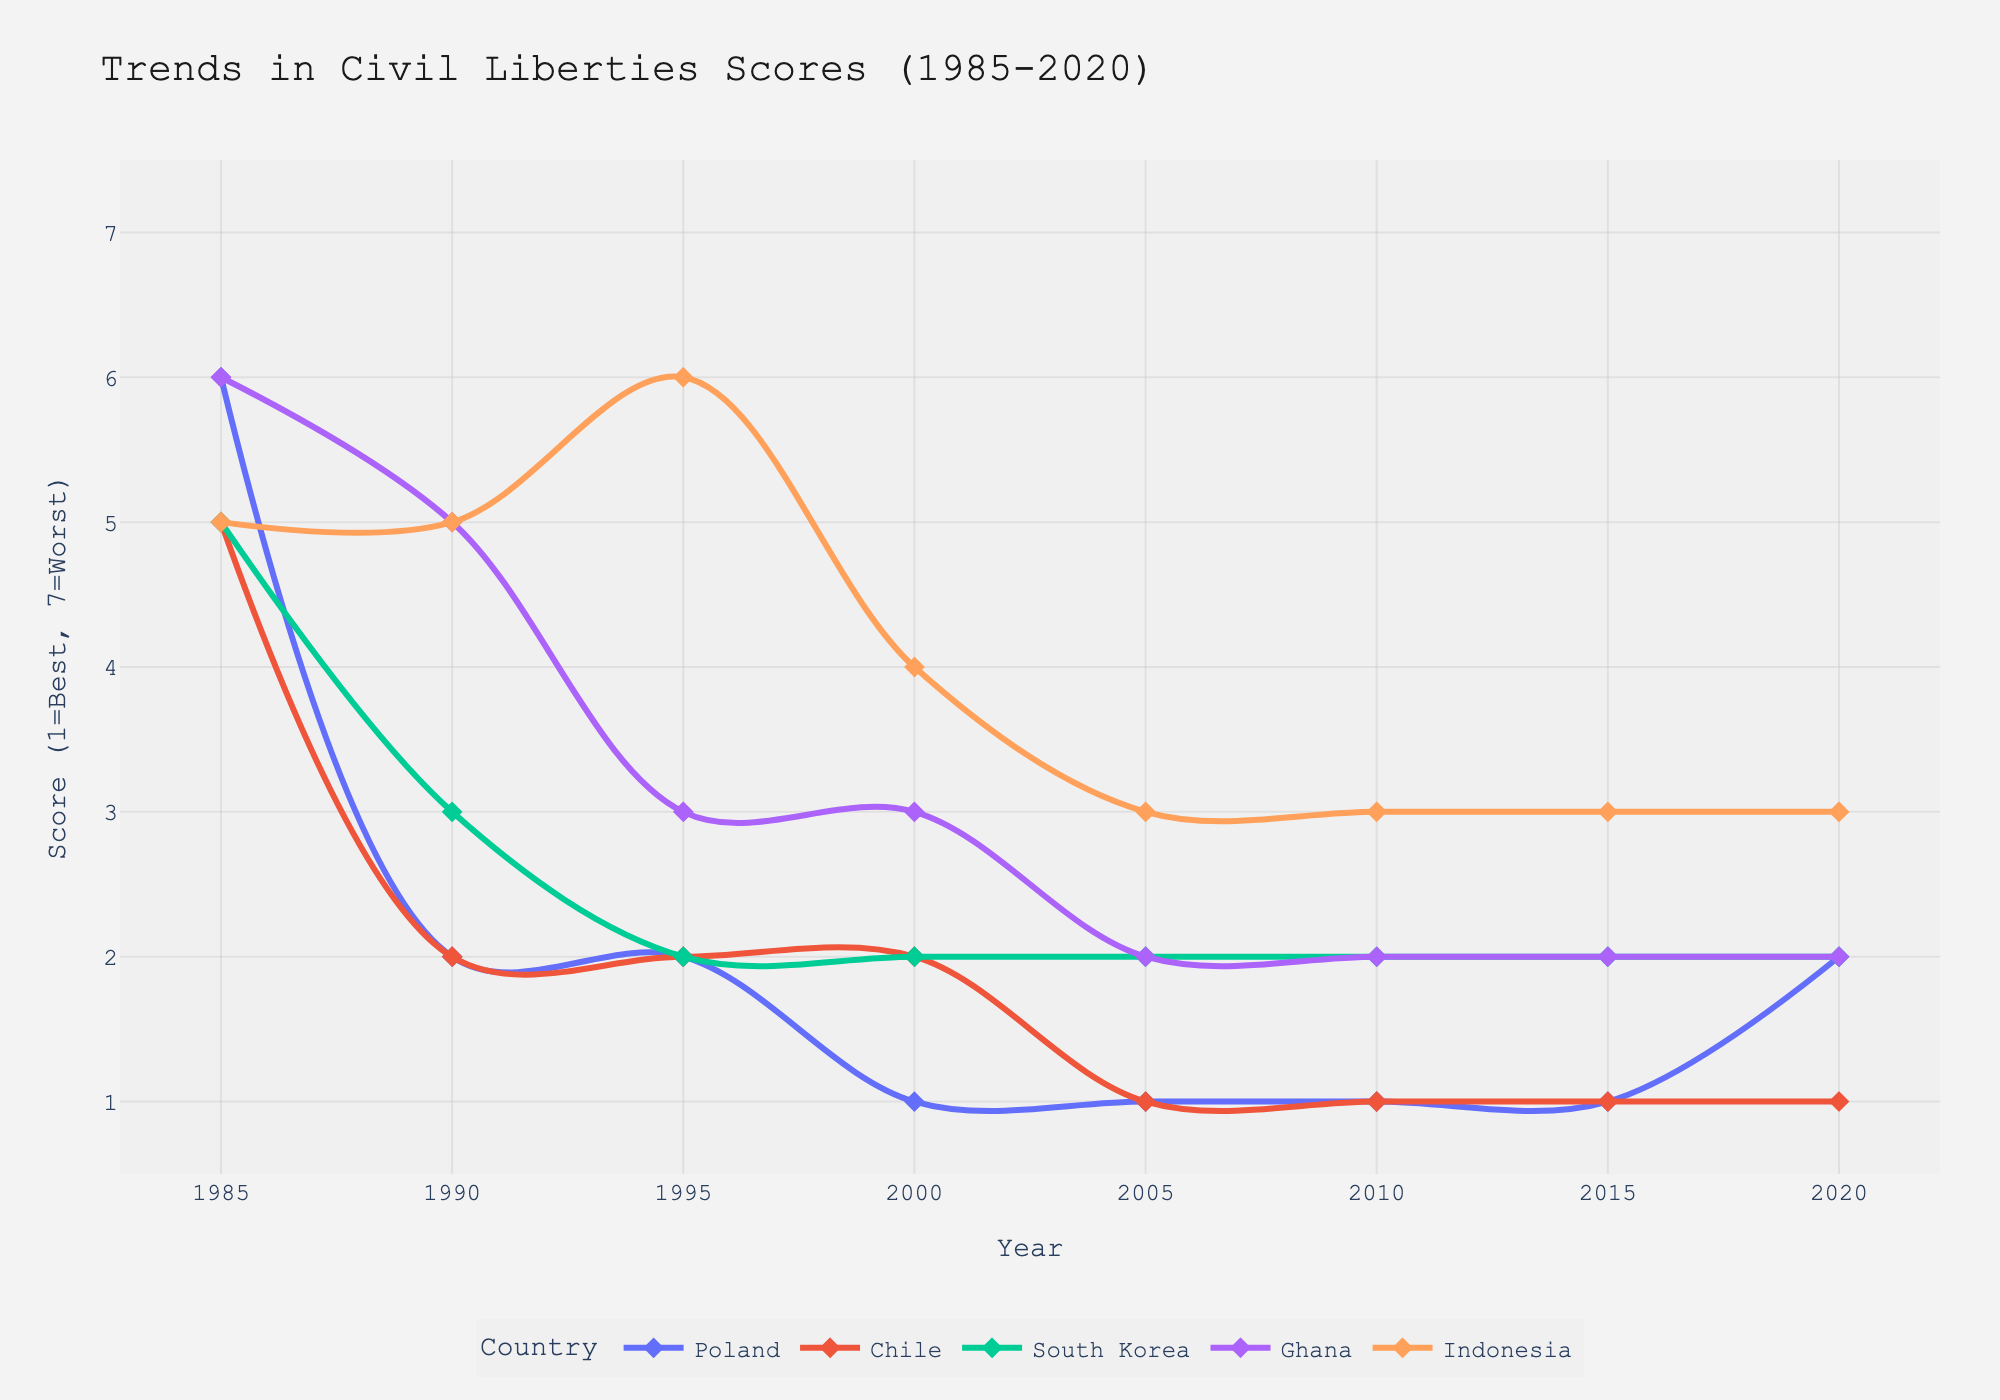Which country's civil liberties score showed the most improvement from 1985 to 2020? To determine which country showed the most improvement, we need to look at the difference in civil liberties scores between 1985 and 2020 for each country. Poland improved from a score of 6 to 2, Chile improved from 5 to 1, South Korea improved from 5 to 2, Ghana improved from 6 to 2, and Indonesia improved from 5 to 3. Chile had the largest improvement, with a decrease of 4 points.
Answer: Chile Which country had the highest civil liberties score in 2020? By inspecting the Civil Liberties Scores for 2020, we see that the scores are: Poland (2), Chile (1), South Korea (2), Ghana (2), and Indonesia (3). The highest score among these is 3.
Answer: Indonesia What is the average Civil Liberties Score of South Korea from 1985 to 2020? Calculate the average by summing all scores for South Korea and dividing by the number of data points: (5+3+2+2+2+2+2+2)=20, so the average is 20/8.
Answer: 2.5 Did any country experience an increase in Civil Liberties Score from 2015 to 2020? By comparing the civil liberties scores of 2015 and 2020, we see that Poland increased from 1 to 2, while the other countries remained the same.
Answer: Poland Between Poland and Ghana, which country had a lower Civil Liberties Score in 1990? In 1990, Poland had a score of 2, and Ghana had a score of 5. Poland had the lower score.
Answer: Poland In what year did Indonesia have the worst Civil Liberties Score, and what was the score? Inspect the line representing Indonesia. The worst score for Indonesia was 6, which occurred in 1995.
Answer: 1995, 6 Which country had the lowest Civil Liberties Score in 2000? In 2000, the scores were: Poland (1), Chile (2), South Korea (2), Ghana (3), and Indonesia (4). Poland had the lowest score.
Answer: Poland During the transition period from dictatorship to democracy, which country consistently had a Civil Liberties Score of 2 from 2000 to 2020? By examining the line chart, we see that only South Korea had a consistent score of 2 during this period.
Answer: South Korea How does the Civil Liberties Score for Chile in 1985 compare with that of Ghana in the same year? In 1985, Chile had a score of 5, and Ghana had a score of 6. Chile's score was lower.
Answer: Chile Compare the Civil Liberties Score improvement of Poland and Indonesia between 1995 and 2005. Poland's score improved from 2 in 1995 to 1 in 2005, an improvement of 1 point. Indonesia's score improved from 6 in 1995 to 3 in 2005, an improvement of 3 points. Indonesia showed a greater improvement.
Answer: Indonesia 